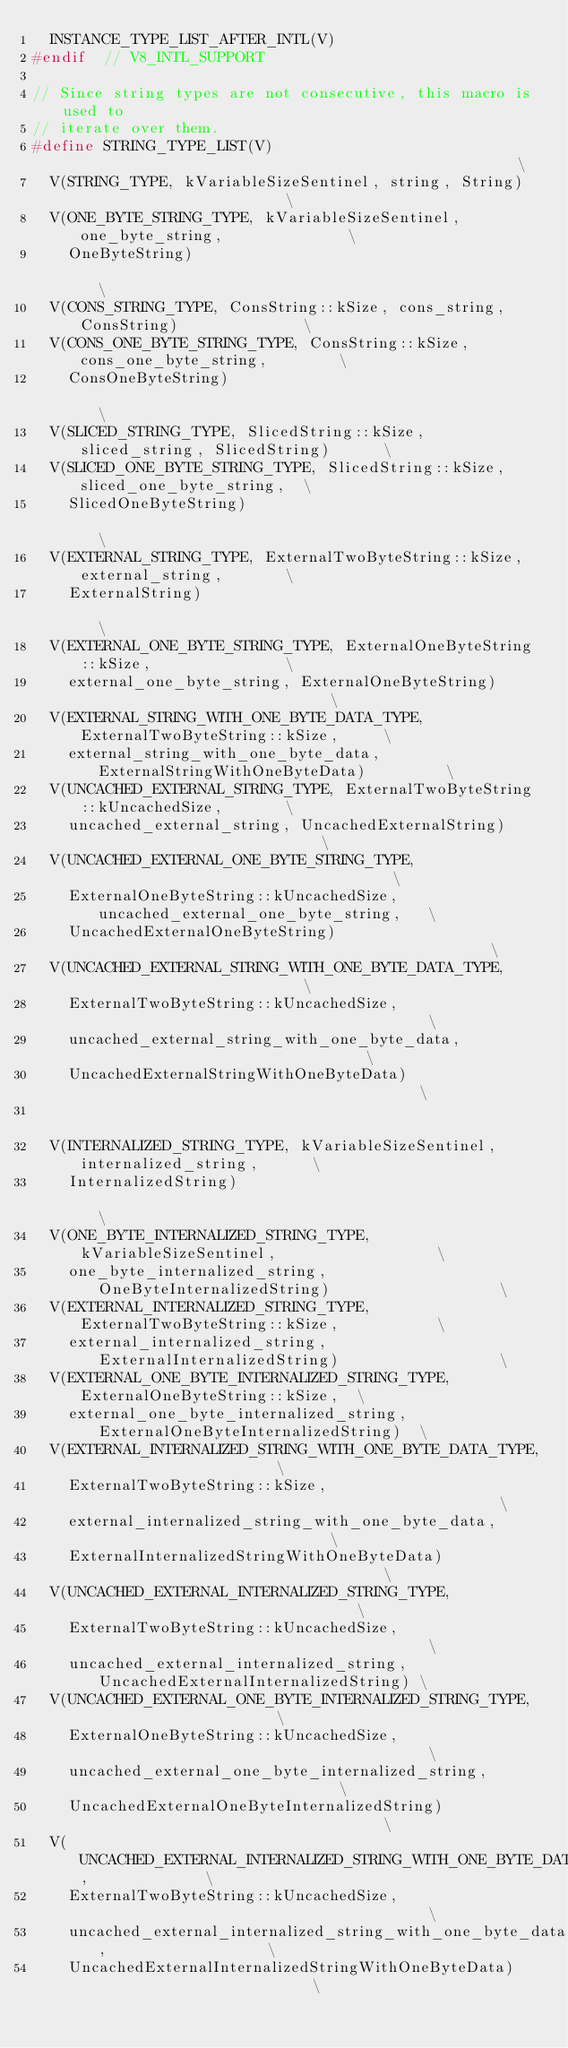Convert code to text. <code><loc_0><loc_0><loc_500><loc_500><_C_>  INSTANCE_TYPE_LIST_AFTER_INTL(V)
#endif  // V8_INTL_SUPPORT

// Since string types are not consecutive, this macro is used to
// iterate over them.
#define STRING_TYPE_LIST(V)                                                    \
  V(STRING_TYPE, kVariableSizeSentinel, string, String)                        \
  V(ONE_BYTE_STRING_TYPE, kVariableSizeSentinel, one_byte_string,              \
    OneByteString)                                                             \
  V(CONS_STRING_TYPE, ConsString::kSize, cons_string, ConsString)              \
  V(CONS_ONE_BYTE_STRING_TYPE, ConsString::kSize, cons_one_byte_string,        \
    ConsOneByteString)                                                         \
  V(SLICED_STRING_TYPE, SlicedString::kSize, sliced_string, SlicedString)      \
  V(SLICED_ONE_BYTE_STRING_TYPE, SlicedString::kSize, sliced_one_byte_string,  \
    SlicedOneByteString)                                                       \
  V(EXTERNAL_STRING_TYPE, ExternalTwoByteString::kSize, external_string,       \
    ExternalString)                                                            \
  V(EXTERNAL_ONE_BYTE_STRING_TYPE, ExternalOneByteString::kSize,               \
    external_one_byte_string, ExternalOneByteString)                           \
  V(EXTERNAL_STRING_WITH_ONE_BYTE_DATA_TYPE, ExternalTwoByteString::kSize,     \
    external_string_with_one_byte_data, ExternalStringWithOneByteData)         \
  V(UNCACHED_EXTERNAL_STRING_TYPE, ExternalTwoByteString::kUncachedSize,       \
    uncached_external_string, UncachedExternalString)                          \
  V(UNCACHED_EXTERNAL_ONE_BYTE_STRING_TYPE,                                    \
    ExternalOneByteString::kUncachedSize, uncached_external_one_byte_string,   \
    UncachedExternalOneByteString)                                             \
  V(UNCACHED_EXTERNAL_STRING_WITH_ONE_BYTE_DATA_TYPE,                          \
    ExternalTwoByteString::kUncachedSize,                                      \
    uncached_external_string_with_one_byte_data,                               \
    UncachedExternalStringWithOneByteData)                                     \
                                                                               \
  V(INTERNALIZED_STRING_TYPE, kVariableSizeSentinel, internalized_string,      \
    InternalizedString)                                                        \
  V(ONE_BYTE_INTERNALIZED_STRING_TYPE, kVariableSizeSentinel,                  \
    one_byte_internalized_string, OneByteInternalizedString)                   \
  V(EXTERNAL_INTERNALIZED_STRING_TYPE, ExternalTwoByteString::kSize,           \
    external_internalized_string, ExternalInternalizedString)                  \
  V(EXTERNAL_ONE_BYTE_INTERNALIZED_STRING_TYPE, ExternalOneByteString::kSize,  \
    external_one_byte_internalized_string, ExternalOneByteInternalizedString)  \
  V(EXTERNAL_INTERNALIZED_STRING_WITH_ONE_BYTE_DATA_TYPE,                      \
    ExternalTwoByteString::kSize,                                              \
    external_internalized_string_with_one_byte_data,                           \
    ExternalInternalizedStringWithOneByteData)                                 \
  V(UNCACHED_EXTERNAL_INTERNALIZED_STRING_TYPE,                                \
    ExternalTwoByteString::kUncachedSize,                                      \
    uncached_external_internalized_string, UncachedExternalInternalizedString) \
  V(UNCACHED_EXTERNAL_ONE_BYTE_INTERNALIZED_STRING_TYPE,                       \
    ExternalOneByteString::kUncachedSize,                                      \
    uncached_external_one_byte_internalized_string,                            \
    UncachedExternalOneByteInternalizedString)                                 \
  V(UNCACHED_EXTERNAL_INTERNALIZED_STRING_WITH_ONE_BYTE_DATA_TYPE,             \
    ExternalTwoByteString::kUncachedSize,                                      \
    uncached_external_internalized_string_with_one_byte_data,                  \
    UncachedExternalInternalizedStringWithOneByteData)                         \</code> 